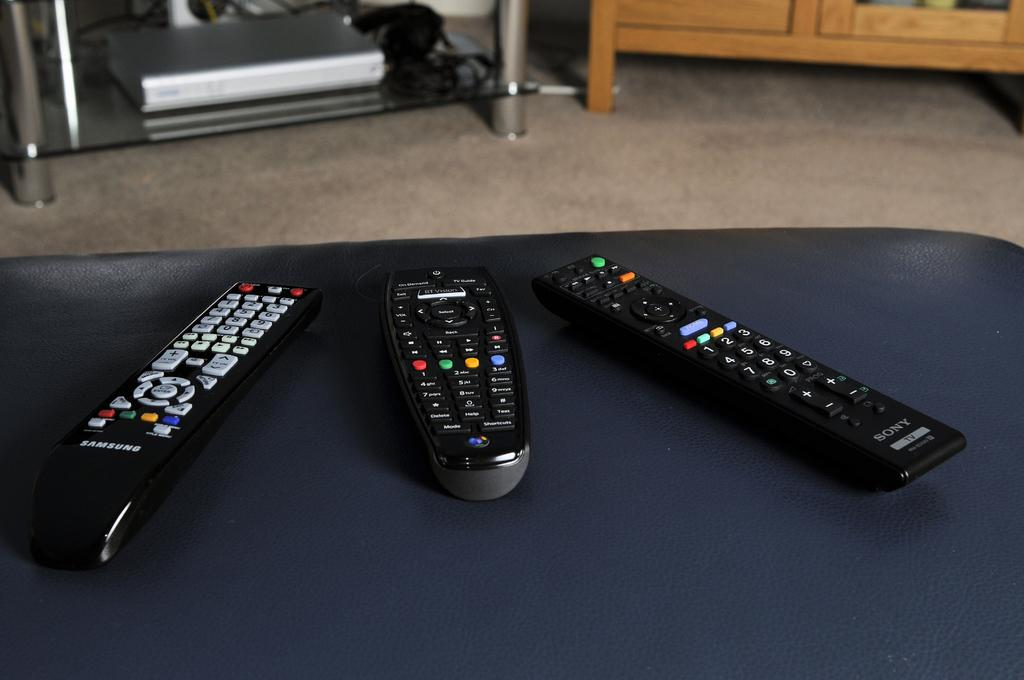<image>
Create a compact narrative representing the image presented. the word Samsung is on the front of a remote 